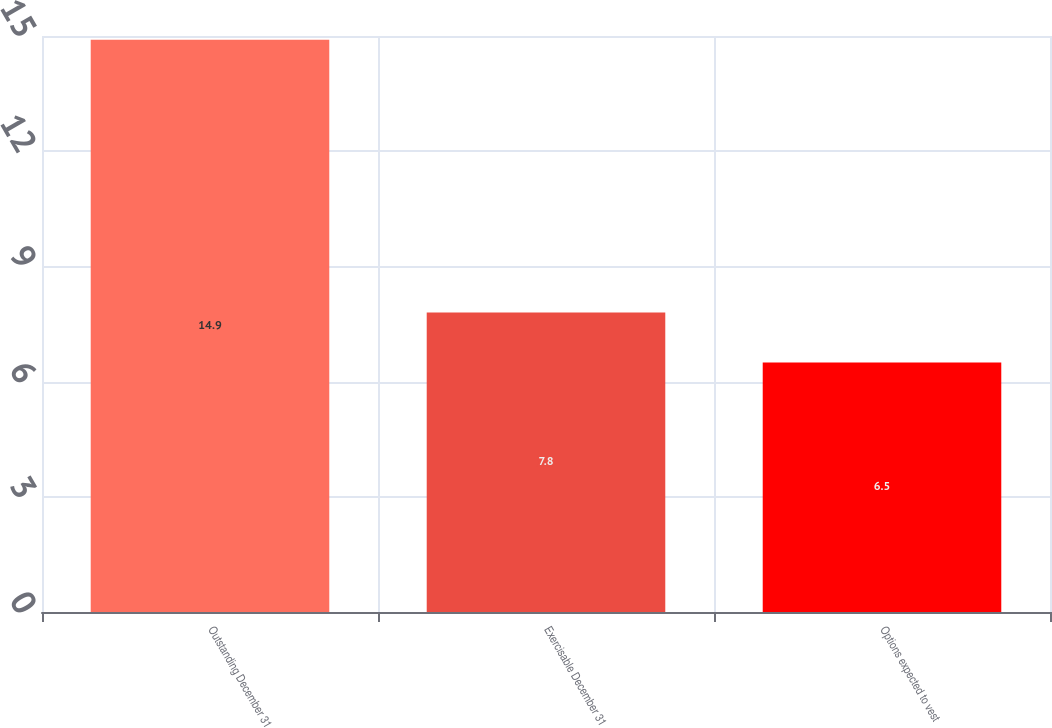Convert chart to OTSL. <chart><loc_0><loc_0><loc_500><loc_500><bar_chart><fcel>Outstanding December 31<fcel>Exercisable December 31<fcel>Options expected to vest<nl><fcel>14.9<fcel>7.8<fcel>6.5<nl></chart> 